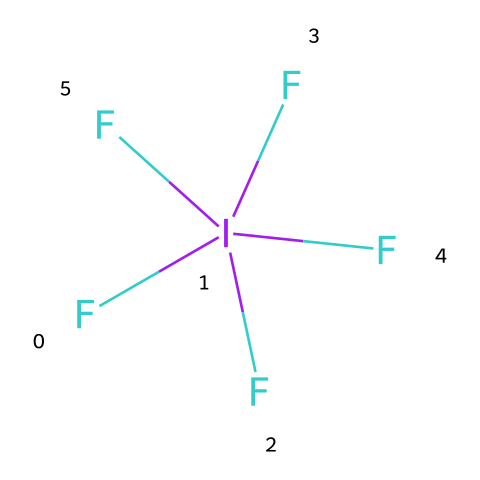What is the total number of fluorine atoms in iodine pentafluoride? In the SMILES representation, there are five fluorine atoms attached to the iodine atom, as indicated by the notation (F)(F)(F)(F)F, which denotes multiple fluorine bonds to the central iodine.
Answer: five How many atoms are present in the molecule? The total count includes one iodine atom and five fluorine atoms, leading to a total of six atoms in the molecule (1 iodine + 5 fluorine = 6).
Answer: six What is the oxidation state of iodine in this compound? Iodine pentafluoride contains iodine with five covalent bonds to fluorine. Given that each fluorine contributes a -1 charge, the oxidation state of iodine can be calculated as 5 * (-1) from fluorine, resulting in an oxidation state of +5 (to balance the overall neutral charge of the molecule).
Answer: +5 Does iodine pentafluoride have a hypervalent structure? The compound's structure is hypervalent because iodine, a third-period element, is bonded to more than four atoms (specifically five); this property helps iodine achieve a stable electronic configuration though it exceeds the octet rule.
Answer: yes What type of bonding involves the interactions in iodine pentafluoride? The interactions in iodine pentafluoride primarily consist of covalent bonding due to the sharing of electron pairs between iodine and fluorine atoms to form strong bonds, a characteristic of nonmetals.
Answer: covalent Is iodine pentafluoride a strong oxidizing agent? Iodine pentafluoride acts as a strong oxidizing agent due to its high electronegativity and ability to accept electrons readily from other substances, enhancing its reactivity in redox reactions.
Answer: yes 